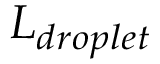<formula> <loc_0><loc_0><loc_500><loc_500>L _ { d r o p l e t }</formula> 